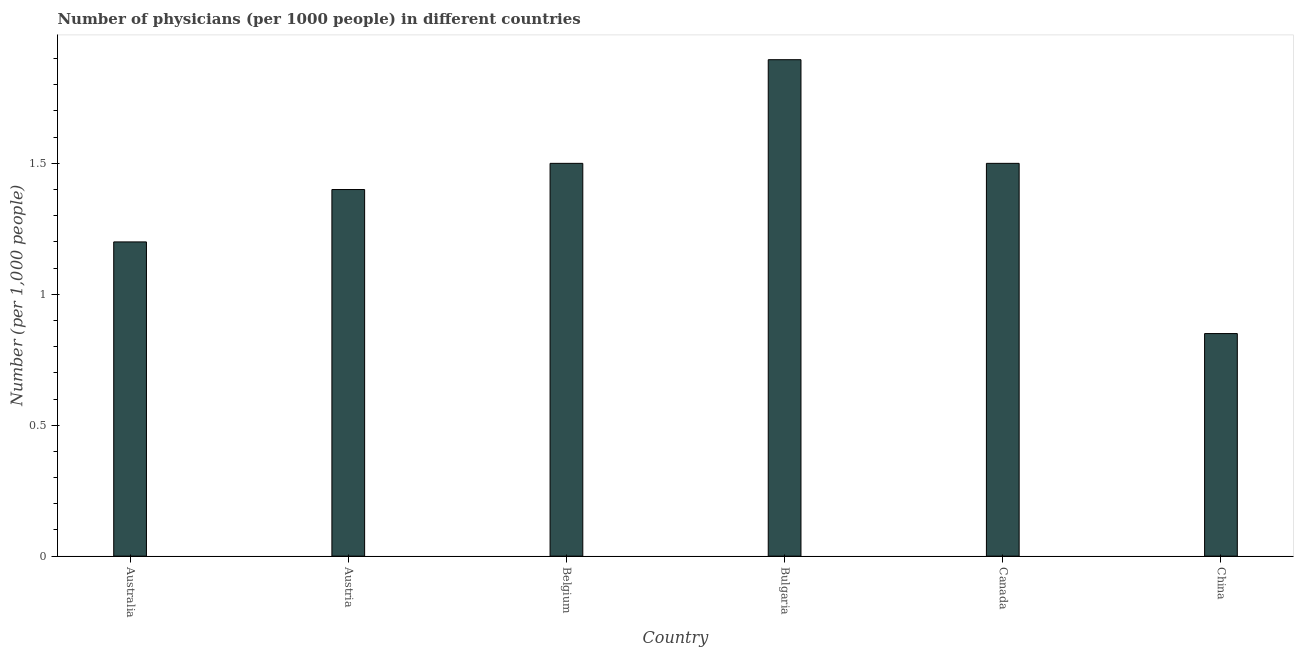Does the graph contain any zero values?
Ensure brevity in your answer.  No. What is the title of the graph?
Your answer should be very brief. Number of physicians (per 1000 people) in different countries. What is the label or title of the Y-axis?
Offer a very short reply. Number (per 1,0 people). What is the number of physicians in Bulgaria?
Provide a short and direct response. 1.9. Across all countries, what is the maximum number of physicians?
Offer a terse response. 1.9. Across all countries, what is the minimum number of physicians?
Offer a very short reply. 0.85. In which country was the number of physicians minimum?
Offer a terse response. China. What is the sum of the number of physicians?
Your response must be concise. 8.35. What is the difference between the number of physicians in Canada and China?
Offer a very short reply. 0.65. What is the average number of physicians per country?
Offer a terse response. 1.39. What is the median number of physicians?
Offer a very short reply. 1.45. Is the number of physicians in Austria less than that in Belgium?
Keep it short and to the point. Yes. Is the difference between the number of physicians in Australia and China greater than the difference between any two countries?
Your answer should be compact. No. What is the difference between the highest and the second highest number of physicians?
Offer a very short reply. 0.4. Is the sum of the number of physicians in Bulgaria and Canada greater than the maximum number of physicians across all countries?
Your answer should be compact. Yes. What is the difference between the highest and the lowest number of physicians?
Ensure brevity in your answer.  1.05. In how many countries, is the number of physicians greater than the average number of physicians taken over all countries?
Offer a terse response. 4. Are the values on the major ticks of Y-axis written in scientific E-notation?
Your answer should be very brief. No. What is the Number (per 1,000 people) in Australia?
Your answer should be compact. 1.2. What is the Number (per 1,000 people) in Bulgaria?
Provide a succinct answer. 1.9. What is the Number (per 1,000 people) in China?
Make the answer very short. 0.85. What is the difference between the Number (per 1,000 people) in Australia and Belgium?
Make the answer very short. -0.3. What is the difference between the Number (per 1,000 people) in Australia and Bulgaria?
Give a very brief answer. -0.7. What is the difference between the Number (per 1,000 people) in Australia and Canada?
Provide a succinct answer. -0.3. What is the difference between the Number (per 1,000 people) in Austria and Bulgaria?
Make the answer very short. -0.5. What is the difference between the Number (per 1,000 people) in Austria and China?
Give a very brief answer. 0.55. What is the difference between the Number (per 1,000 people) in Belgium and Bulgaria?
Provide a short and direct response. -0.4. What is the difference between the Number (per 1,000 people) in Belgium and Canada?
Provide a short and direct response. 0. What is the difference between the Number (per 1,000 people) in Belgium and China?
Your answer should be very brief. 0.65. What is the difference between the Number (per 1,000 people) in Bulgaria and Canada?
Provide a succinct answer. 0.4. What is the difference between the Number (per 1,000 people) in Bulgaria and China?
Ensure brevity in your answer.  1.05. What is the difference between the Number (per 1,000 people) in Canada and China?
Make the answer very short. 0.65. What is the ratio of the Number (per 1,000 people) in Australia to that in Austria?
Keep it short and to the point. 0.86. What is the ratio of the Number (per 1,000 people) in Australia to that in Belgium?
Give a very brief answer. 0.8. What is the ratio of the Number (per 1,000 people) in Australia to that in Bulgaria?
Keep it short and to the point. 0.63. What is the ratio of the Number (per 1,000 people) in Australia to that in China?
Offer a very short reply. 1.41. What is the ratio of the Number (per 1,000 people) in Austria to that in Belgium?
Your answer should be compact. 0.93. What is the ratio of the Number (per 1,000 people) in Austria to that in Bulgaria?
Provide a short and direct response. 0.74. What is the ratio of the Number (per 1,000 people) in Austria to that in Canada?
Offer a terse response. 0.93. What is the ratio of the Number (per 1,000 people) in Austria to that in China?
Provide a short and direct response. 1.65. What is the ratio of the Number (per 1,000 people) in Belgium to that in Bulgaria?
Provide a succinct answer. 0.79. What is the ratio of the Number (per 1,000 people) in Belgium to that in Canada?
Make the answer very short. 1. What is the ratio of the Number (per 1,000 people) in Belgium to that in China?
Your response must be concise. 1.76. What is the ratio of the Number (per 1,000 people) in Bulgaria to that in Canada?
Your answer should be very brief. 1.26. What is the ratio of the Number (per 1,000 people) in Bulgaria to that in China?
Provide a succinct answer. 2.23. What is the ratio of the Number (per 1,000 people) in Canada to that in China?
Ensure brevity in your answer.  1.76. 